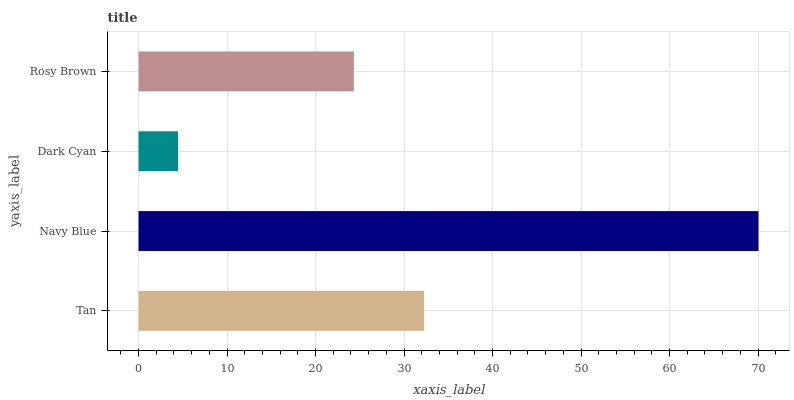Is Dark Cyan the minimum?
Answer yes or no. Yes. Is Navy Blue the maximum?
Answer yes or no. Yes. Is Navy Blue the minimum?
Answer yes or no. No. Is Dark Cyan the maximum?
Answer yes or no. No. Is Navy Blue greater than Dark Cyan?
Answer yes or no. Yes. Is Dark Cyan less than Navy Blue?
Answer yes or no. Yes. Is Dark Cyan greater than Navy Blue?
Answer yes or no. No. Is Navy Blue less than Dark Cyan?
Answer yes or no. No. Is Tan the high median?
Answer yes or no. Yes. Is Rosy Brown the low median?
Answer yes or no. Yes. Is Dark Cyan the high median?
Answer yes or no. No. Is Navy Blue the low median?
Answer yes or no. No. 